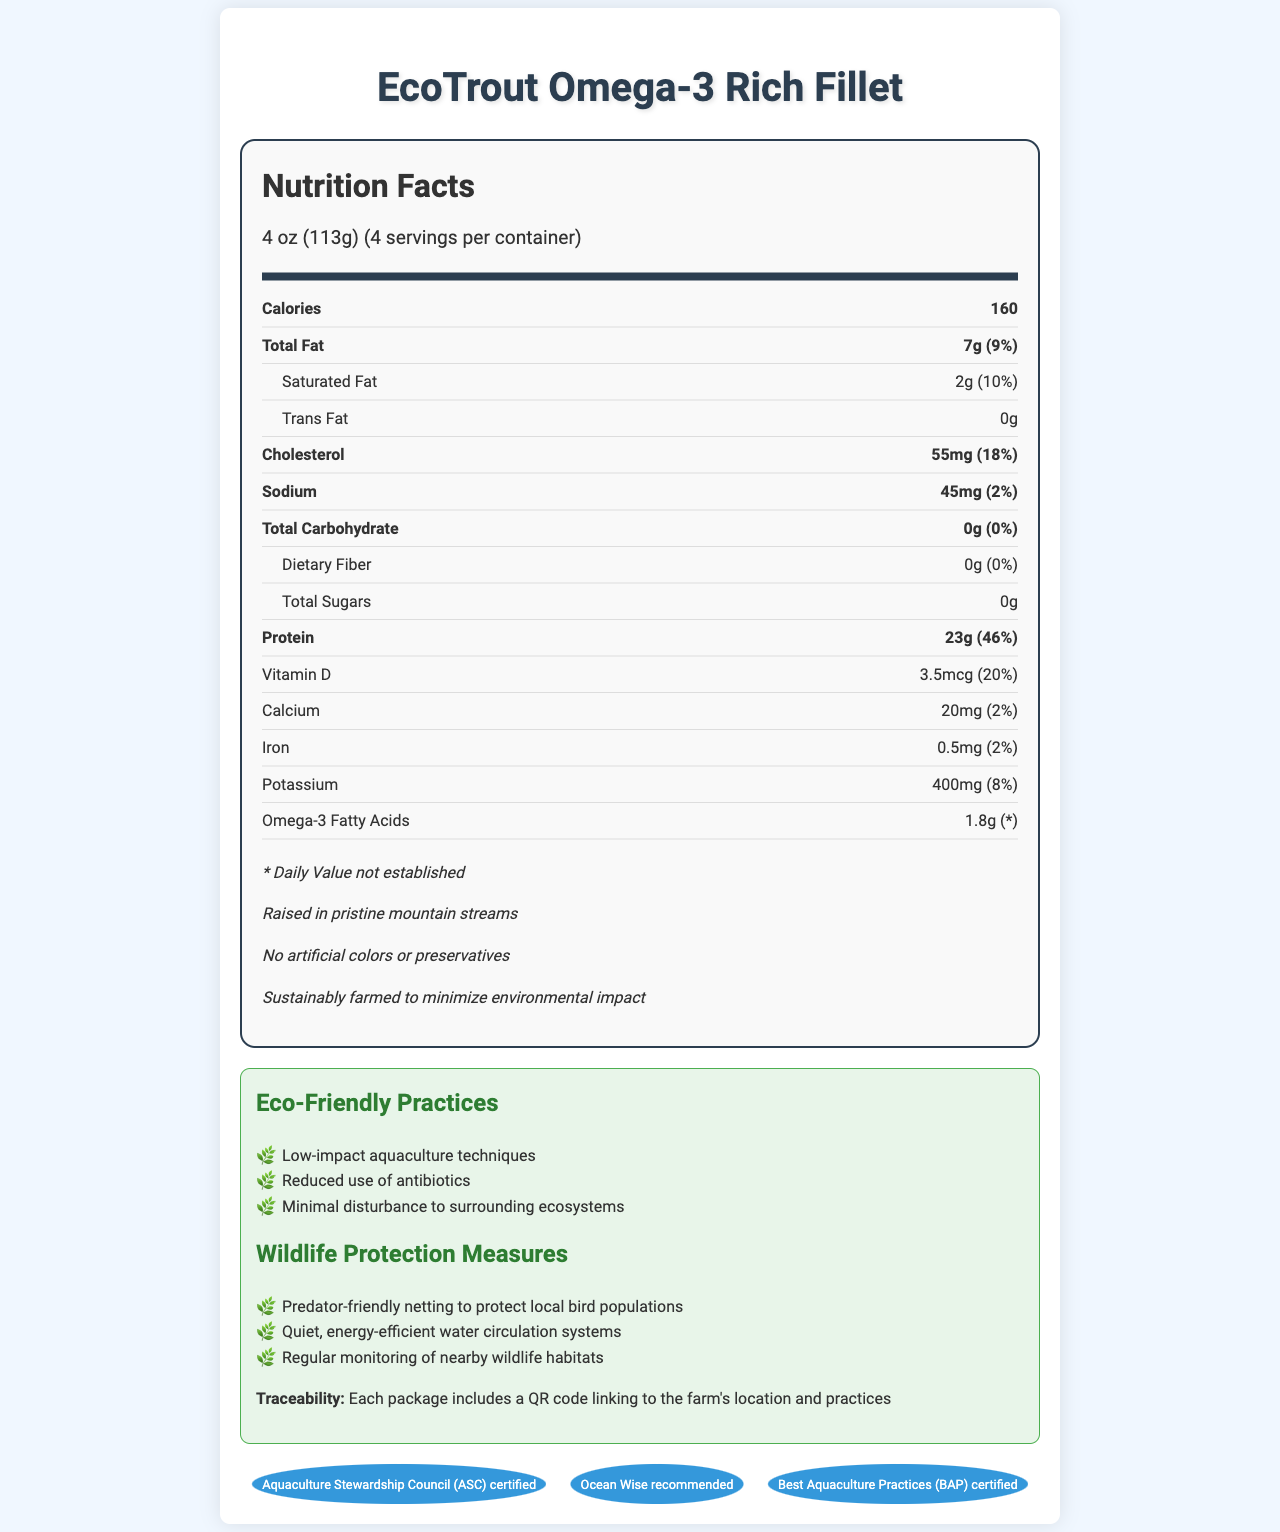what is the product name? The product name is displayed at the top of the document.
Answer: EcoTrout Omega-3 Rich Fillet what is the serving size? The serving size is mentioned in the serving information section.
Answer: 4 oz (113g) how many calories are in each serving? The calories per serving are listed in the main nutrient information.
Answer: 160 what is the Daily Value percentage for protein? The Daily Value percentage for protein is shown next to the protein amount.
Answer: 46% how much omega-3 fatty acids does each serving contain? The omega-3 fatty acids content is specified in the nutrient details.
Answer: 1.8g which certification does EcoTrout have? A. USDA Organic B. ASC certified C. Certified Humane D. Non-GMO Project Verified The certification listed in the document includes "Aquaculture Stewardship Council (ASC) certified".
Answer: B what are the eco-friendly practices mentioned? A. Low-impact aquaculture techniques B. No artificial colors C. Reduced use of antibiotics D. All of the above The eco-friendly practices include low-impact aquaculture techniques, reduced use of antibiotics, and minimal disturbance to surrounding ecosystems.
Answer: D is the product free of artificial colors? The additional info section states "No artificial colors or preservatives".
Answer: Yes describe the sustainability measures mentioned in the document. The eco-friendly practices and wildlife protection measures sections provide details about the sustainability efforts implemented.
Answer: The document highlights various sustainability measures such as low-impact aquaculture techniques, predator-friendly netting to protect local bird populations, quiet and energy-efficient water circulation systems, and regular monitoring of nearby wildlife habitats. Additionally, the product is raised in pristine mountain streams and does not contain artificial colors or preservatives. It is also ASC-certified, Ocean Wise recommended, and Best Aquaculture Practices (BAP) certified. what is the source farm location for this product? The document mentions a QR code for tracing the farm's location but does not provide the actual location.
Answer: Cannot be determined what is the percentage of daily value for vitamin D? The vitamin D percentage is listed in the nutrient facts section right next to its amount.
Answer: 20% how much sodium does one serving contain? The sodium content for one serving is located under the main nutrient information.
Answer: 45mg does the product contain trans fat? The trans fat amount is specified as "0g" in the nutrient facts.
Answer: No what are the main benefits of the product according to the document? The entire document emphasizes the nutritional value, especially the omega-3 content, and the eco-friendly and sustainable practices used in farming the product.
Answer: The main benefits include high omega-3 content, sustainable farming practices, no artificial colors or preservatives, and multiple certifications ensuring quality and environmental care. 